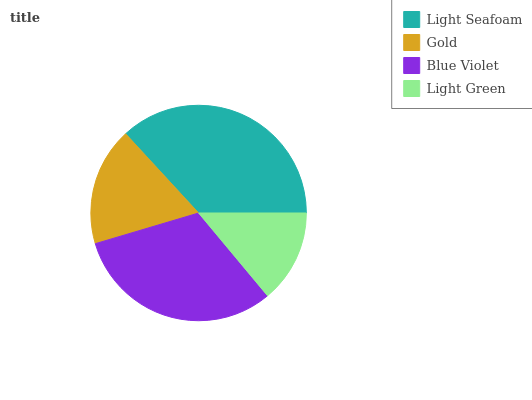Is Light Green the minimum?
Answer yes or no. Yes. Is Light Seafoam the maximum?
Answer yes or no. Yes. Is Gold the minimum?
Answer yes or no. No. Is Gold the maximum?
Answer yes or no. No. Is Light Seafoam greater than Gold?
Answer yes or no. Yes. Is Gold less than Light Seafoam?
Answer yes or no. Yes. Is Gold greater than Light Seafoam?
Answer yes or no. No. Is Light Seafoam less than Gold?
Answer yes or no. No. Is Blue Violet the high median?
Answer yes or no. Yes. Is Gold the low median?
Answer yes or no. Yes. Is Gold the high median?
Answer yes or no. No. Is Light Seafoam the low median?
Answer yes or no. No. 